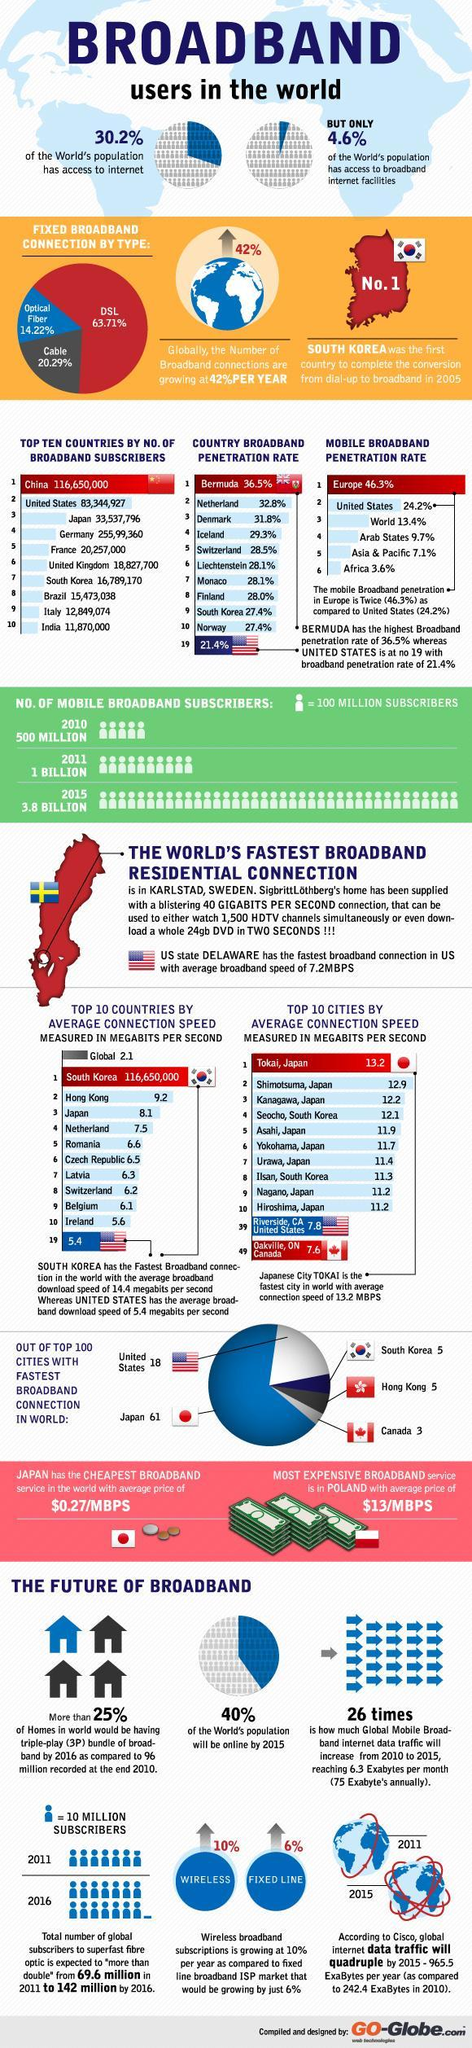What is the percentage increase in the wireless broadband connection per year?
Answer the question with a short phrase. 10% What percent of the world's population will be online by 2015? 40% What percent of the world's population do not have access to the internet? 69.8% What is the broadband penetration rate in South Korea? 27.4% Which type of broadband connection is used by the least number of users in the world? Optical Fiber Which type of broadband connection is used by the majority of broadband users in the world? DSL Which country has the second highest number of broadband subscribers? United States What percentage of broadband users use optical fibre connection in the world? 14.22% What is the number of mobile broadband subscribers in 2011? 1 BILLION Which country has the highest number of broadband subscribers? China 